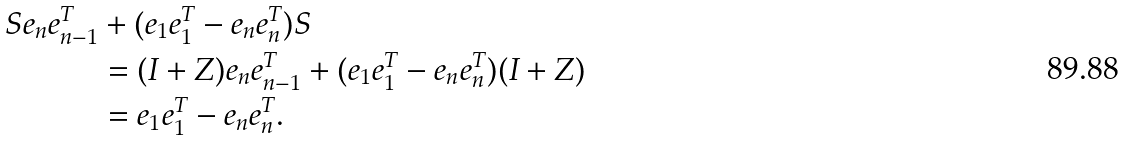<formula> <loc_0><loc_0><loc_500><loc_500>S e _ { n } e _ { n - 1 } ^ { T } & + ( e _ { 1 } e _ { 1 } ^ { T } - e _ { n } e _ { n } ^ { T } ) S \\ & = ( I + Z ) e _ { n } e _ { n - 1 } ^ { T } + ( e _ { 1 } e _ { 1 } ^ { T } - e _ { n } e _ { n } ^ { T } ) ( I + Z ) \\ & = e _ { 1 } e _ { 1 } ^ { T } - e _ { n } e _ { n } ^ { T } .</formula> 